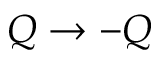<formula> <loc_0><loc_0><loc_500><loc_500>Q \rightarrow - Q</formula> 